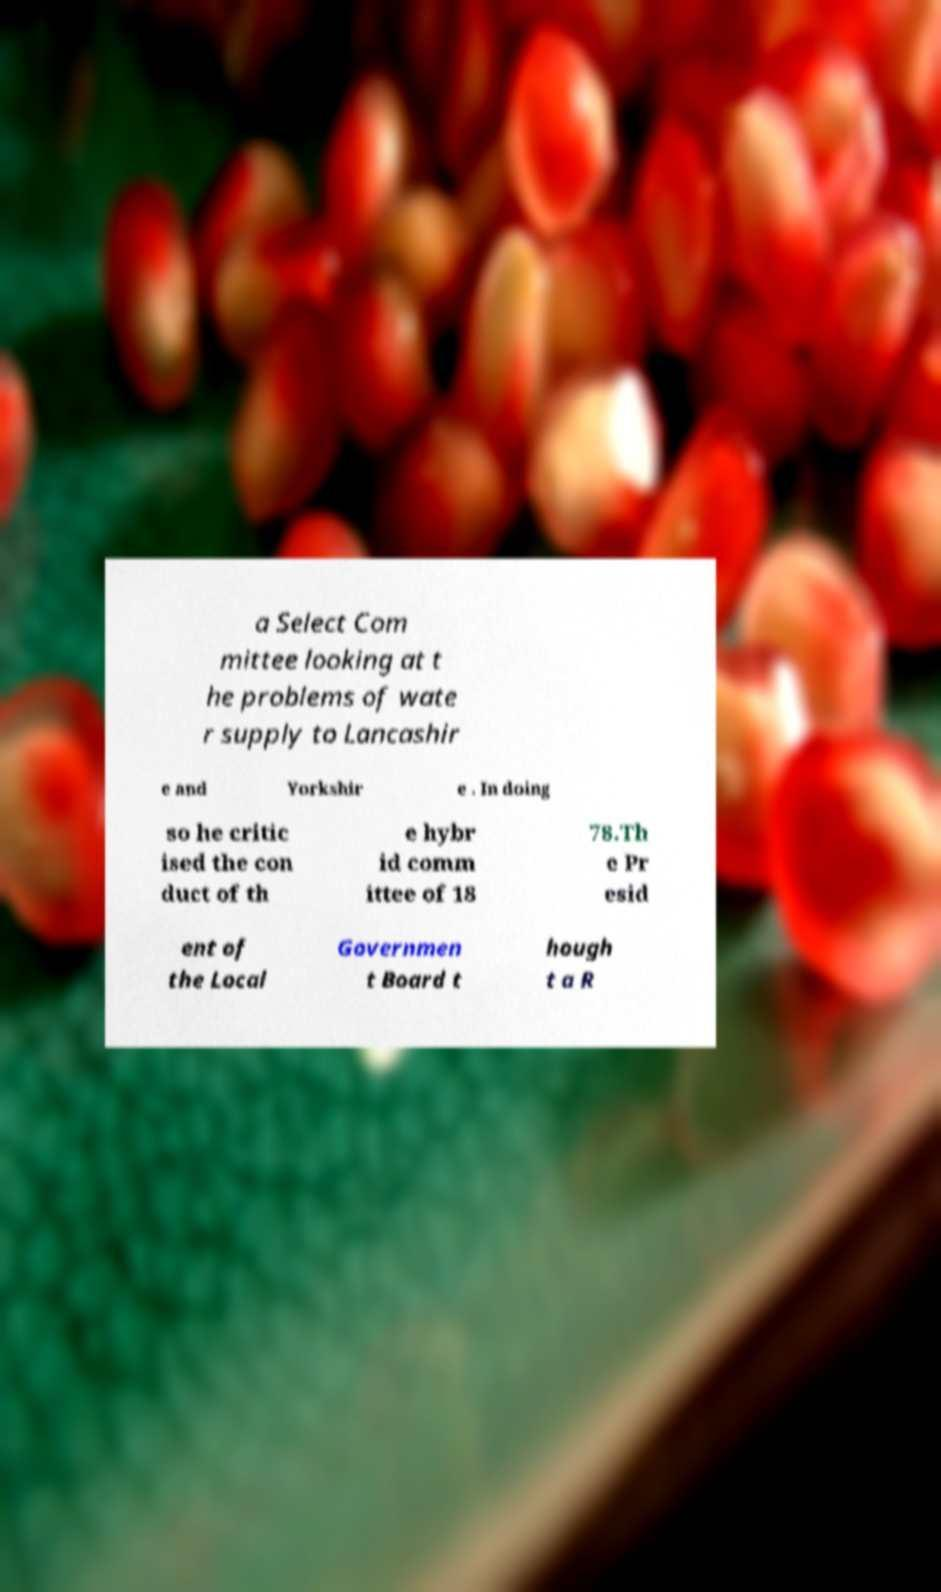Please identify and transcribe the text found in this image. a Select Com mittee looking at t he problems of wate r supply to Lancashir e and Yorkshir e . In doing so he critic ised the con duct of th e hybr id comm ittee of 18 78.Th e Pr esid ent of the Local Governmen t Board t hough t a R 